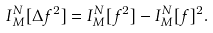<formula> <loc_0><loc_0><loc_500><loc_500>I ^ { N } _ { M } [ \Delta f ^ { 2 } ] = I ^ { N } _ { M } [ f ^ { 2 } ] - I ^ { N } _ { M } [ f ] ^ { 2 } .</formula> 